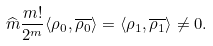Convert formula to latex. <formula><loc_0><loc_0><loc_500><loc_500>\widehat { m } \frac { m ! } { 2 ^ { m } } \langle \rho _ { 0 } , \overline { \rho _ { 0 } } \rangle = \langle \rho _ { 1 } , \overline { \rho _ { 1 } } \rangle \not = 0 .</formula> 